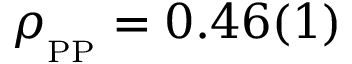<formula> <loc_0><loc_0><loc_500><loc_500>\rho _ { _ { P P } } = 0 . 4 6 ( 1 )</formula> 